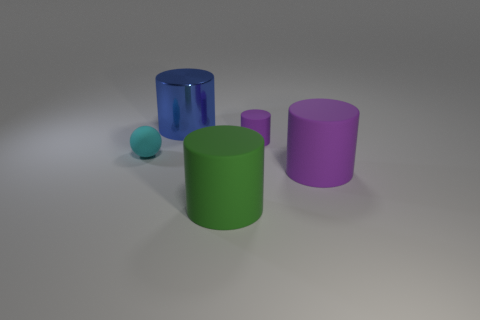What is the color of the object that is on the left side of the tiny cylinder and behind the cyan object?
Keep it short and to the point. Blue. Is the number of large objects that are behind the green matte object greater than the number of big yellow metallic things?
Offer a terse response. Yes. Is there a small purple matte cylinder?
Keep it short and to the point. Yes. How many large objects are either cyan matte things or rubber things?
Offer a terse response. 2. Is there any other thing of the same color as the small cylinder?
Offer a terse response. Yes. What shape is the purple thing that is made of the same material as the large purple cylinder?
Ensure brevity in your answer.  Cylinder. What size is the matte thing that is to the left of the blue metal object?
Provide a short and direct response. Small. What shape is the big green thing?
Your response must be concise. Cylinder. Do the matte cylinder behind the ball and the object left of the blue metal cylinder have the same size?
Your response must be concise. Yes. There is a purple object that is in front of the thing on the left side of the blue shiny cylinder behind the small rubber sphere; how big is it?
Offer a terse response. Large. 